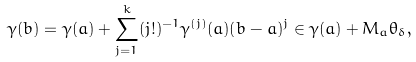<formula> <loc_0><loc_0><loc_500><loc_500>\gamma ( b ) = \gamma ( a ) + \sum _ { j = 1 } ^ { k } ( j ! ) ^ { - 1 } \gamma ^ { ( j ) } ( a ) ( b - a ) ^ { j } \in \gamma ( a ) + M _ { a } \theta _ { \delta } ,</formula> 